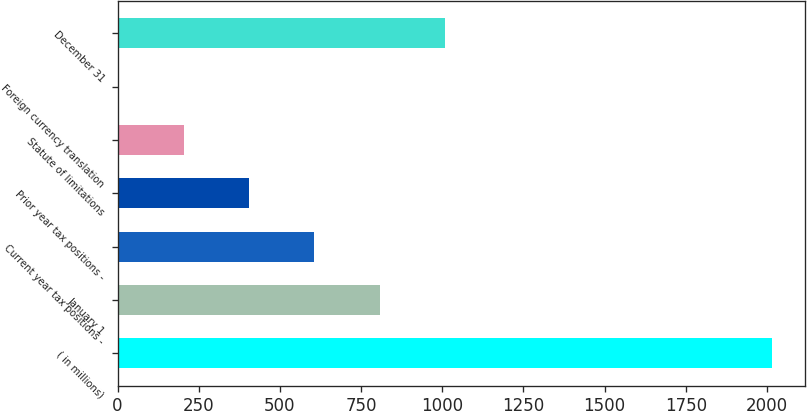Convert chart to OTSL. <chart><loc_0><loc_0><loc_500><loc_500><bar_chart><fcel>( in millions)<fcel>January 1<fcel>Current year tax positions -<fcel>Prior year tax positions -<fcel>Statute of limitations<fcel>Foreign currency translation<fcel>December 31<nl><fcel>2016<fcel>807.6<fcel>606.2<fcel>404.8<fcel>203.4<fcel>2<fcel>1009<nl></chart> 